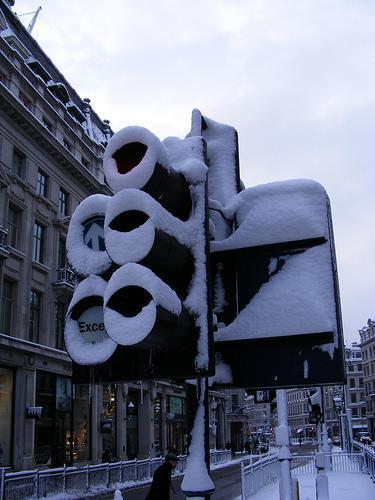How many men crossing the street?
Give a very brief answer. 2. 